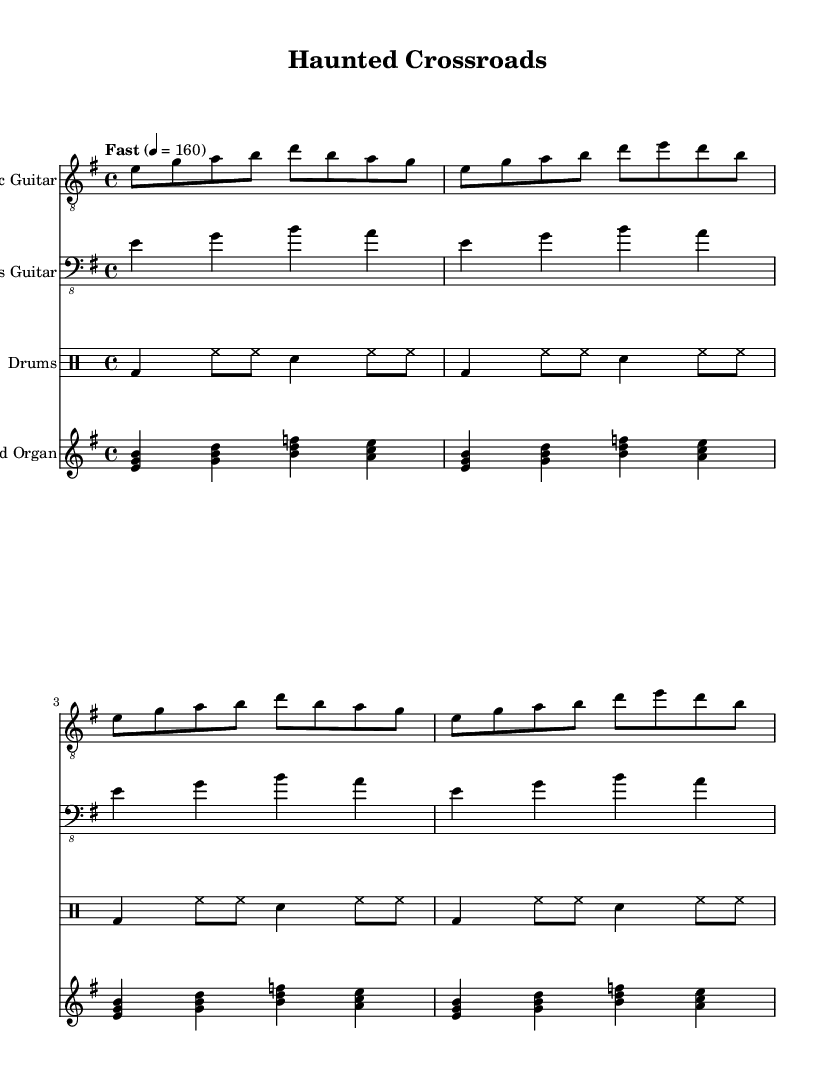What is the key signature of this music? The key signature shows two sharps, which indicates it is in E minor.
Answer: E minor What is the time signature of the piece? The time signature is indicated at the beginning of the score, showing four beats per measure.
Answer: 4/4 What is the tempo marking of the music? The tempo marking indicates that the music should be played fast, specifically at a quarter note equals 160 beats per minute.
Answer: Fast, 4 = 160 How many measures are there in the electric guitar part? By counting the distinct segments of notes in the electric guitar staff, there are a total of four measures.
Answer: 4 What instruments are included in this score? The score features an electric guitar, bass guitar, drums, and a Hammond organ.
Answer: Electric guitar, bass guitar, drums, Hammond organ In which genre is this composition classified? The composition structurally and stylistically aligns with elements characteristic of electric blues, often influenced by horror movie soundtracks.
Answer: Electric blues 